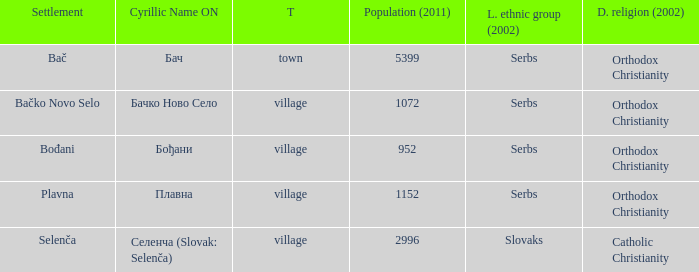What is the ethnic majority in the only town? Serbs. 